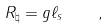Convert formula to latex. <formula><loc_0><loc_0><loc_500><loc_500>R _ { \natural } = g \ell _ { s } \quad ,</formula> 